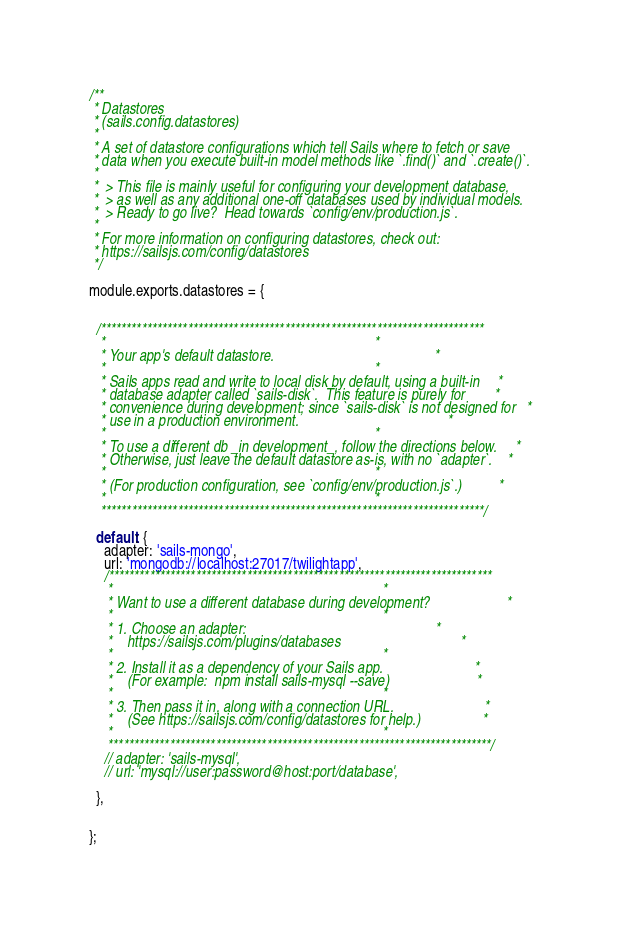<code> <loc_0><loc_0><loc_500><loc_500><_JavaScript_>/**
 * Datastores
 * (sails.config.datastores)
 *
 * A set of datastore configurations which tell Sails where to fetch or save
 * data when you execute built-in model methods like `.find()` and `.create()`.
 *
 *  > This file is mainly useful for configuring your development database,
 *  > as well as any additional one-off databases used by individual models.
 *  > Ready to go live?  Head towards `config/env/production.js`.
 *
 * For more information on configuring datastores, check out:
 * https://sailsjs.com/config/datastores
 */

module.exports.datastores = {


  /***************************************************************************
   *                                                                          *
   * Your app's default datastore.                                            *
   *                                                                          *
   * Sails apps read and write to local disk by default, using a built-in     *
   * database adapter called `sails-disk`.  This feature is purely for        *
   * convenience during development; since `sails-disk` is not designed for   *
   * use in a production environment.                                         *
   *                                                                          *
   * To use a different db _in development_, follow the directions below.     *
   * Otherwise, just leave the default datastore as-is, with no `adapter`.    *
   *                                                                          *
   * (For production configuration, see `config/env/production.js`.)          *
   *                                                                          *
   ***************************************************************************/

  default: {
    adapter: 'sails-mongo',
    url: 'mongodb://localhost:27017/twilightapp',
    /***************************************************************************
     *                                                                          *
     * Want to use a different database during development?                     *
     *                                                                          *
     * 1. Choose an adapter:                                                    *
     *    https://sailsjs.com/plugins/databases                                 *
     *                                                                          *
     * 2. Install it as a dependency of your Sails app.                         *
     *    (For example:  npm install sails-mysql --save)                        *
     *                                                                          *
     * 3. Then pass it in, along with a connection URL.                         *
     *    (See https://sailsjs.com/config/datastores for help.)                 *
     *                                                                          *
     ***************************************************************************/
    // adapter: 'sails-mysql',
    // url: 'mysql://user:password@host:port/database',

  },


};
</code> 